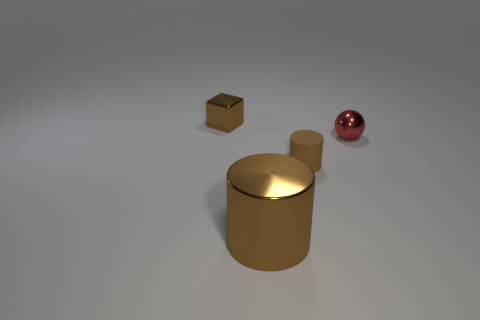There is a brown object that is behind the big brown metal cylinder and on the right side of the block; what material is it?
Offer a very short reply. Rubber. There is a shiny cylinder that is the same color as the small matte thing; what is its size?
Offer a terse response. Large. What number of other things are there of the same size as the brown rubber cylinder?
Offer a very short reply. 2. There is a small brown object right of the large brown metallic cylinder; what material is it?
Make the answer very short. Rubber. Do the big metal object and the tiny rubber object have the same shape?
Provide a succinct answer. Yes. How many other objects are the same shape as the red shiny object?
Offer a very short reply. 0. There is a metallic object in front of the tiny sphere; what is its color?
Provide a succinct answer. Brown. Do the brown shiny cube and the rubber thing have the same size?
Keep it short and to the point. Yes. What is the material of the small brown object in front of the brown metallic object left of the big brown metallic object?
Provide a short and direct response. Rubber. What number of things have the same color as the tiny block?
Your response must be concise. 2. 